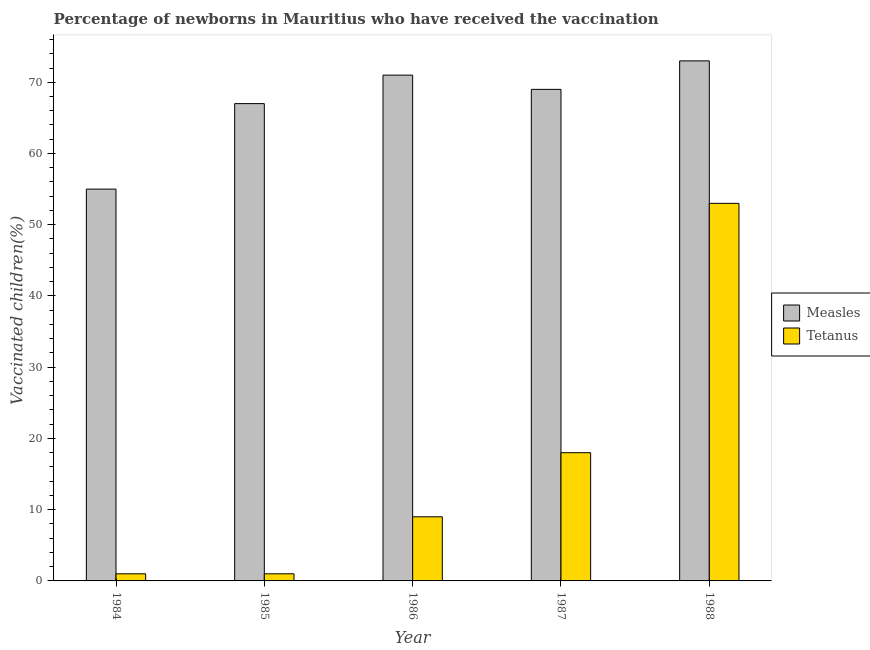How many different coloured bars are there?
Make the answer very short. 2. How many groups of bars are there?
Give a very brief answer. 5. Are the number of bars per tick equal to the number of legend labels?
Your answer should be compact. Yes. Are the number of bars on each tick of the X-axis equal?
Provide a short and direct response. Yes. How many bars are there on the 3rd tick from the right?
Make the answer very short. 2. What is the label of the 2nd group of bars from the left?
Ensure brevity in your answer.  1985. In how many cases, is the number of bars for a given year not equal to the number of legend labels?
Your answer should be compact. 0. What is the percentage of newborns who received vaccination for measles in 1986?
Ensure brevity in your answer.  71. Across all years, what is the maximum percentage of newborns who received vaccination for tetanus?
Ensure brevity in your answer.  53. Across all years, what is the minimum percentage of newborns who received vaccination for tetanus?
Ensure brevity in your answer.  1. In which year was the percentage of newborns who received vaccination for tetanus minimum?
Provide a short and direct response. 1984. What is the total percentage of newborns who received vaccination for tetanus in the graph?
Make the answer very short. 82. What is the difference between the percentage of newborns who received vaccination for measles in 1986 and that in 1987?
Ensure brevity in your answer.  2. What is the difference between the percentage of newborns who received vaccination for tetanus in 1988 and the percentage of newborns who received vaccination for measles in 1986?
Offer a very short reply. 44. What is the average percentage of newborns who received vaccination for tetanus per year?
Ensure brevity in your answer.  16.4. In how many years, is the percentage of newborns who received vaccination for measles greater than 24 %?
Your response must be concise. 5. What is the ratio of the percentage of newborns who received vaccination for tetanus in 1984 to that in 1987?
Provide a succinct answer. 0.06. Is the percentage of newborns who received vaccination for measles in 1985 less than that in 1988?
Keep it short and to the point. Yes. What is the difference between the highest and the lowest percentage of newborns who received vaccination for measles?
Your response must be concise. 18. In how many years, is the percentage of newborns who received vaccination for tetanus greater than the average percentage of newborns who received vaccination for tetanus taken over all years?
Offer a very short reply. 2. What does the 2nd bar from the left in 1984 represents?
Offer a terse response. Tetanus. What does the 2nd bar from the right in 1986 represents?
Keep it short and to the point. Measles. What is the difference between two consecutive major ticks on the Y-axis?
Make the answer very short. 10. Are the values on the major ticks of Y-axis written in scientific E-notation?
Your answer should be compact. No. Does the graph contain any zero values?
Your response must be concise. No. Does the graph contain grids?
Provide a short and direct response. No. Where does the legend appear in the graph?
Provide a succinct answer. Center right. How many legend labels are there?
Offer a very short reply. 2. What is the title of the graph?
Ensure brevity in your answer.  Percentage of newborns in Mauritius who have received the vaccination. What is the label or title of the X-axis?
Ensure brevity in your answer.  Year. What is the label or title of the Y-axis?
Your response must be concise. Vaccinated children(%)
. What is the Vaccinated children(%)
 of Measles in 1984?
Give a very brief answer. 55. What is the Vaccinated children(%)
 in Tetanus in 1985?
Give a very brief answer. 1. What is the Vaccinated children(%)
 in Measles in 1986?
Offer a very short reply. 71. What is the Vaccinated children(%)
 of Measles in 1987?
Give a very brief answer. 69. What is the Vaccinated children(%)
 of Tetanus in 1987?
Your answer should be compact. 18. Across all years, what is the maximum Vaccinated children(%)
 of Measles?
Ensure brevity in your answer.  73. Across all years, what is the maximum Vaccinated children(%)
 in Tetanus?
Give a very brief answer. 53. What is the total Vaccinated children(%)
 in Measles in the graph?
Your response must be concise. 335. What is the difference between the Vaccinated children(%)
 in Measles in 1984 and that in 1985?
Your response must be concise. -12. What is the difference between the Vaccinated children(%)
 of Tetanus in 1984 and that in 1986?
Provide a succinct answer. -8. What is the difference between the Vaccinated children(%)
 in Tetanus in 1984 and that in 1987?
Provide a short and direct response. -17. What is the difference between the Vaccinated children(%)
 in Tetanus in 1984 and that in 1988?
Offer a very short reply. -52. What is the difference between the Vaccinated children(%)
 in Tetanus in 1985 and that in 1986?
Your response must be concise. -8. What is the difference between the Vaccinated children(%)
 of Tetanus in 1985 and that in 1988?
Offer a very short reply. -52. What is the difference between the Vaccinated children(%)
 of Measles in 1986 and that in 1988?
Ensure brevity in your answer.  -2. What is the difference between the Vaccinated children(%)
 in Tetanus in 1986 and that in 1988?
Your response must be concise. -44. What is the difference between the Vaccinated children(%)
 in Tetanus in 1987 and that in 1988?
Give a very brief answer. -35. What is the difference between the Vaccinated children(%)
 of Measles in 1984 and the Vaccinated children(%)
 of Tetanus in 1986?
Provide a succinct answer. 46. What is the difference between the Vaccinated children(%)
 in Measles in 1985 and the Vaccinated children(%)
 in Tetanus in 1986?
Your answer should be compact. 58. What is the difference between the Vaccinated children(%)
 in Measles in 1985 and the Vaccinated children(%)
 in Tetanus in 1988?
Your answer should be compact. 14. What is the difference between the Vaccinated children(%)
 of Measles in 1986 and the Vaccinated children(%)
 of Tetanus in 1987?
Offer a very short reply. 53. What is the difference between the Vaccinated children(%)
 of Measles in 1987 and the Vaccinated children(%)
 of Tetanus in 1988?
Provide a succinct answer. 16. What is the average Vaccinated children(%)
 of Tetanus per year?
Offer a very short reply. 16.4. In the year 1984, what is the difference between the Vaccinated children(%)
 in Measles and Vaccinated children(%)
 in Tetanus?
Offer a very short reply. 54. In the year 1985, what is the difference between the Vaccinated children(%)
 of Measles and Vaccinated children(%)
 of Tetanus?
Make the answer very short. 66. In the year 1986, what is the difference between the Vaccinated children(%)
 of Measles and Vaccinated children(%)
 of Tetanus?
Provide a short and direct response. 62. What is the ratio of the Vaccinated children(%)
 in Measles in 1984 to that in 1985?
Your answer should be compact. 0.82. What is the ratio of the Vaccinated children(%)
 in Tetanus in 1984 to that in 1985?
Offer a terse response. 1. What is the ratio of the Vaccinated children(%)
 of Measles in 1984 to that in 1986?
Provide a succinct answer. 0.77. What is the ratio of the Vaccinated children(%)
 of Tetanus in 1984 to that in 1986?
Your response must be concise. 0.11. What is the ratio of the Vaccinated children(%)
 in Measles in 1984 to that in 1987?
Keep it short and to the point. 0.8. What is the ratio of the Vaccinated children(%)
 of Tetanus in 1984 to that in 1987?
Ensure brevity in your answer.  0.06. What is the ratio of the Vaccinated children(%)
 in Measles in 1984 to that in 1988?
Give a very brief answer. 0.75. What is the ratio of the Vaccinated children(%)
 of Tetanus in 1984 to that in 1988?
Your response must be concise. 0.02. What is the ratio of the Vaccinated children(%)
 in Measles in 1985 to that in 1986?
Provide a short and direct response. 0.94. What is the ratio of the Vaccinated children(%)
 of Tetanus in 1985 to that in 1986?
Ensure brevity in your answer.  0.11. What is the ratio of the Vaccinated children(%)
 of Tetanus in 1985 to that in 1987?
Offer a terse response. 0.06. What is the ratio of the Vaccinated children(%)
 in Measles in 1985 to that in 1988?
Offer a terse response. 0.92. What is the ratio of the Vaccinated children(%)
 in Tetanus in 1985 to that in 1988?
Ensure brevity in your answer.  0.02. What is the ratio of the Vaccinated children(%)
 of Measles in 1986 to that in 1987?
Your answer should be compact. 1.03. What is the ratio of the Vaccinated children(%)
 of Tetanus in 1986 to that in 1987?
Provide a succinct answer. 0.5. What is the ratio of the Vaccinated children(%)
 of Measles in 1986 to that in 1988?
Your response must be concise. 0.97. What is the ratio of the Vaccinated children(%)
 in Tetanus in 1986 to that in 1988?
Provide a short and direct response. 0.17. What is the ratio of the Vaccinated children(%)
 of Measles in 1987 to that in 1988?
Provide a short and direct response. 0.95. What is the ratio of the Vaccinated children(%)
 of Tetanus in 1987 to that in 1988?
Give a very brief answer. 0.34. What is the difference between the highest and the second highest Vaccinated children(%)
 in Measles?
Make the answer very short. 2. What is the difference between the highest and the second highest Vaccinated children(%)
 of Tetanus?
Your answer should be very brief. 35. What is the difference between the highest and the lowest Vaccinated children(%)
 in Tetanus?
Your answer should be very brief. 52. 